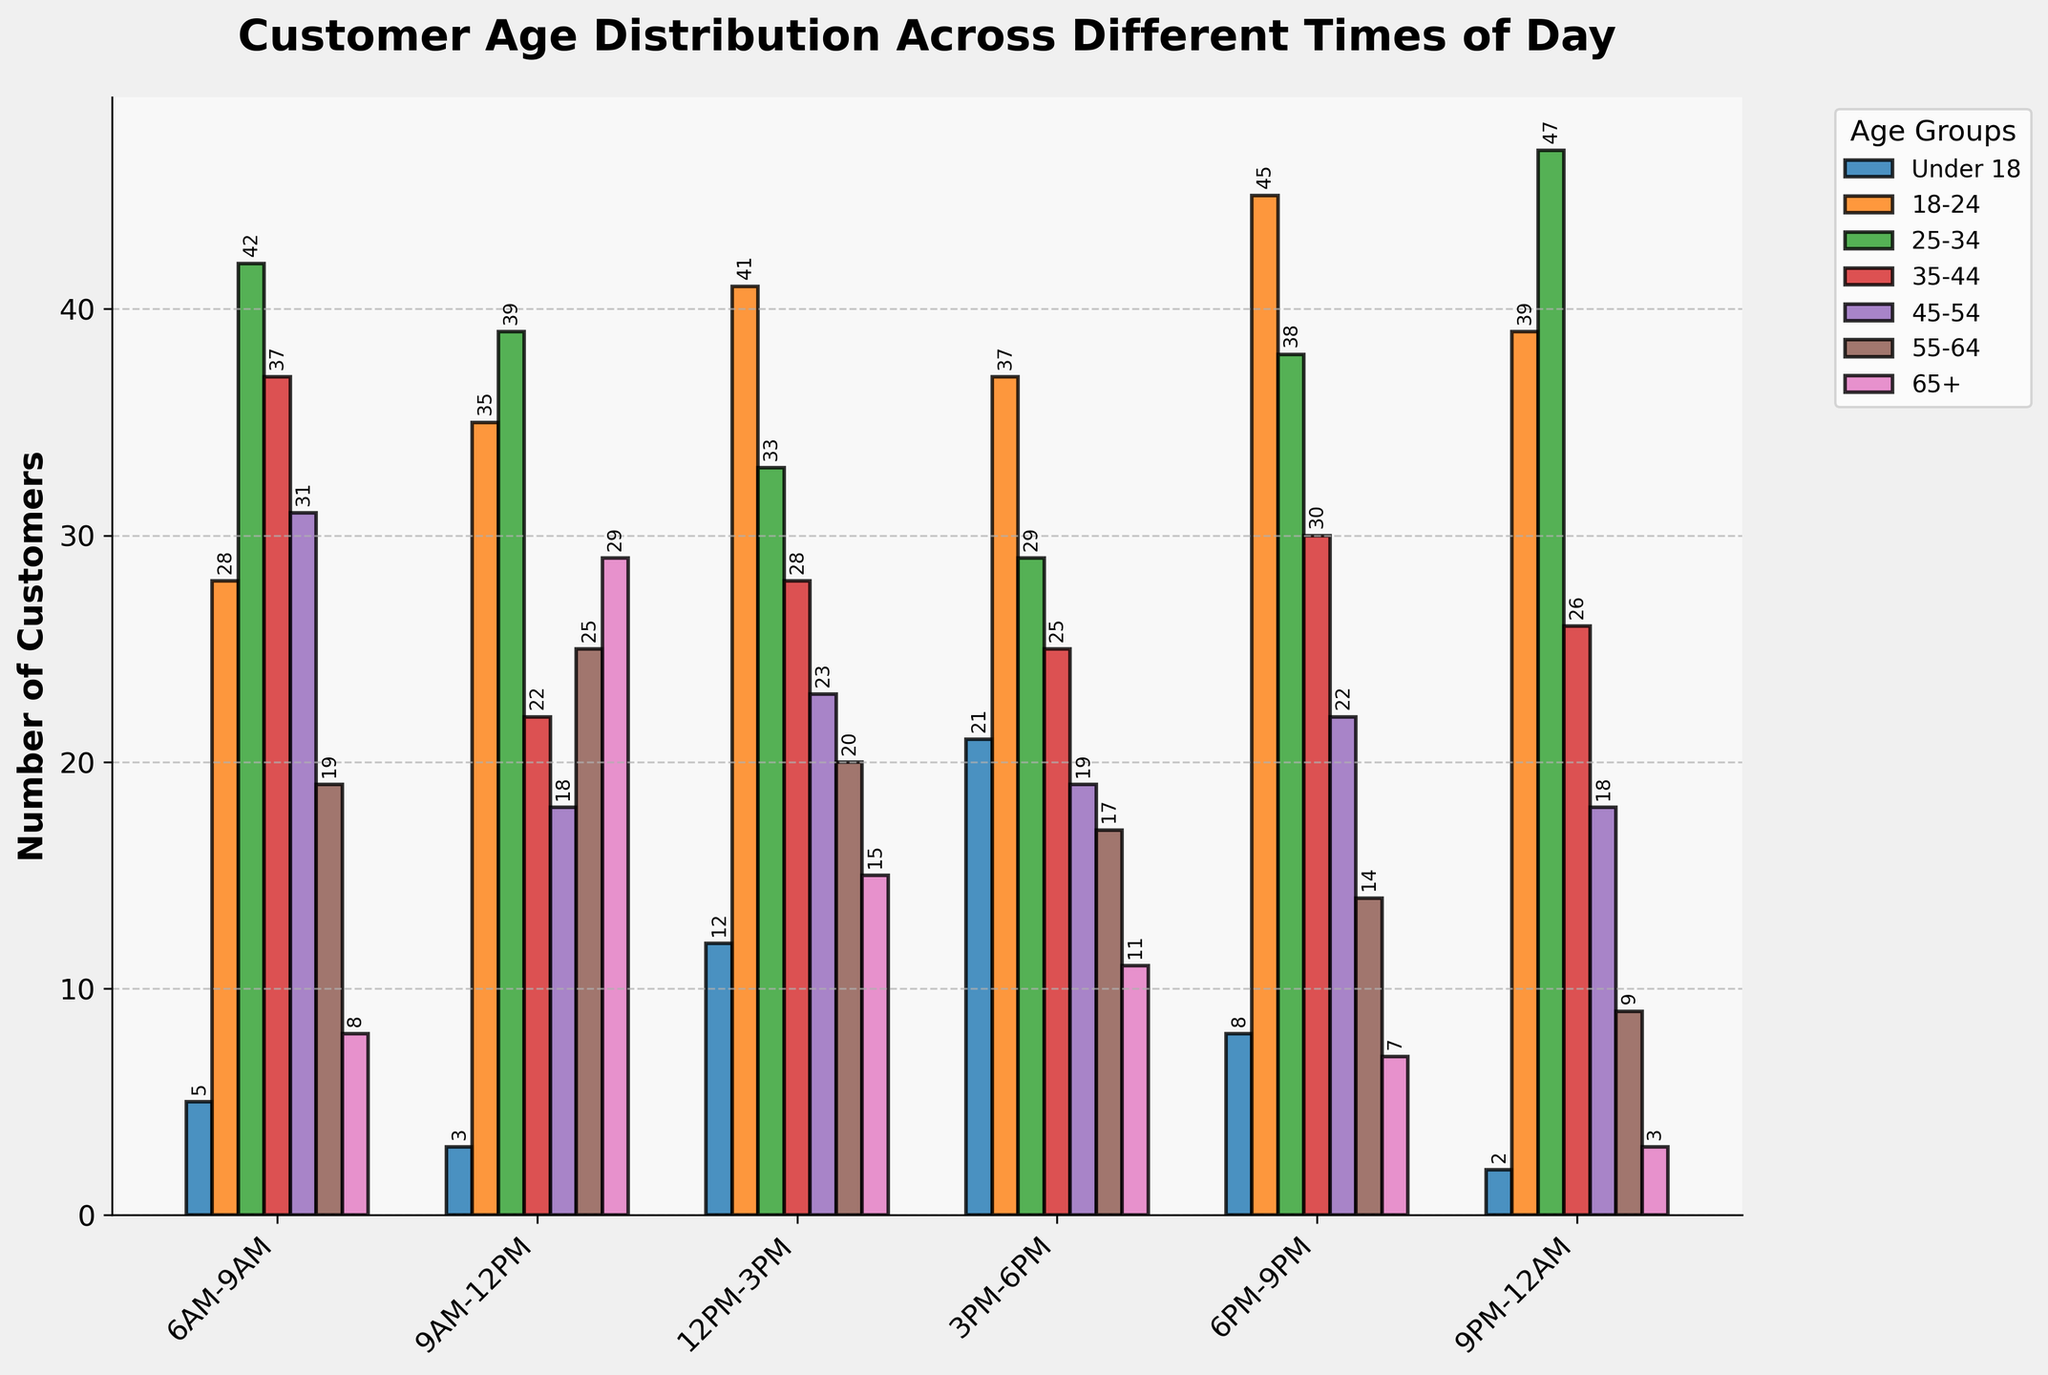What's the most popular time for customers aged 25-34? To find this, look for the tallest bar in the 25-34 age group across different times of day. The tallest bar in the group is at 9PM-12AM with 47 customers.
Answer: 9PM-12AM Which age group has the highest number of customers at 6PM-9PM? Look at the 6PM-9PM slot and identify the tallest bar, which represents the age group with the highest number of customers. The tallest bar is for the 18-24 age group with 45 customers.
Answer: 18-24 What is the total number of customers aged under 18 across all times of day? Add the number of customers under 18 for each time slot: 5+3+12+21+8+2. The total is 51.
Answer: 51 How does the number of 55-64 year-old customers at 9AM-12PM compare to 3PM-6PM? Check the heights of the bars for the 55-64 age group at 9AM-12PM and 3PM-6PM. At 9AM-12PM, there are 25 customers, while at 3PM-6PM, there are 17 customers. 25 is greater than 17.
Answer: 9AM-12PM has more What is the average number of customers for the 45-54 age group across all times of day? Add the number of customers in the 45-54 age group: 31+18+23+19+22+18 and divide by the number of time slots, 6. The sum is 131, so the average is 131/6.
Answer: 21.83 Which time slot has the least number of customers aged 18-24? Identify the shortest bar in the 18-24 age group across all times of day. The shortest bar is at 6AM-9AM with 28 customers.
Answer: 6AM-9AM How many more customers aged 35-44 visited at 6PM-9PM compared to 12PM-3PM? Find the number of customers aged 35-44 for the two time slots and calculate the difference: 30 (6PM-9PM) - 28 (12PM-3PM). The difference is 2.
Answer: 2 What is the proportion of customers aged 65+ during 9PM-12AM to those during 6AM-9AM? Divide the number of customers aged 65+ at 9PM-12AM by the number at 6AM-9AM: 3 / 8. This gives the proportion 0.375.
Answer: 0.375 Which age group shows the biggest increase in the number of customers from 6AM-9AM to 9AM-12PM? Calculate the difference for each age group between the two time slots and identify the maximum: (28-5, 35-3, 39-42, 22-37, 18-31, 25-19, 29-8). The largest increase is 21 for the 65+ age group.
Answer: 65+ 